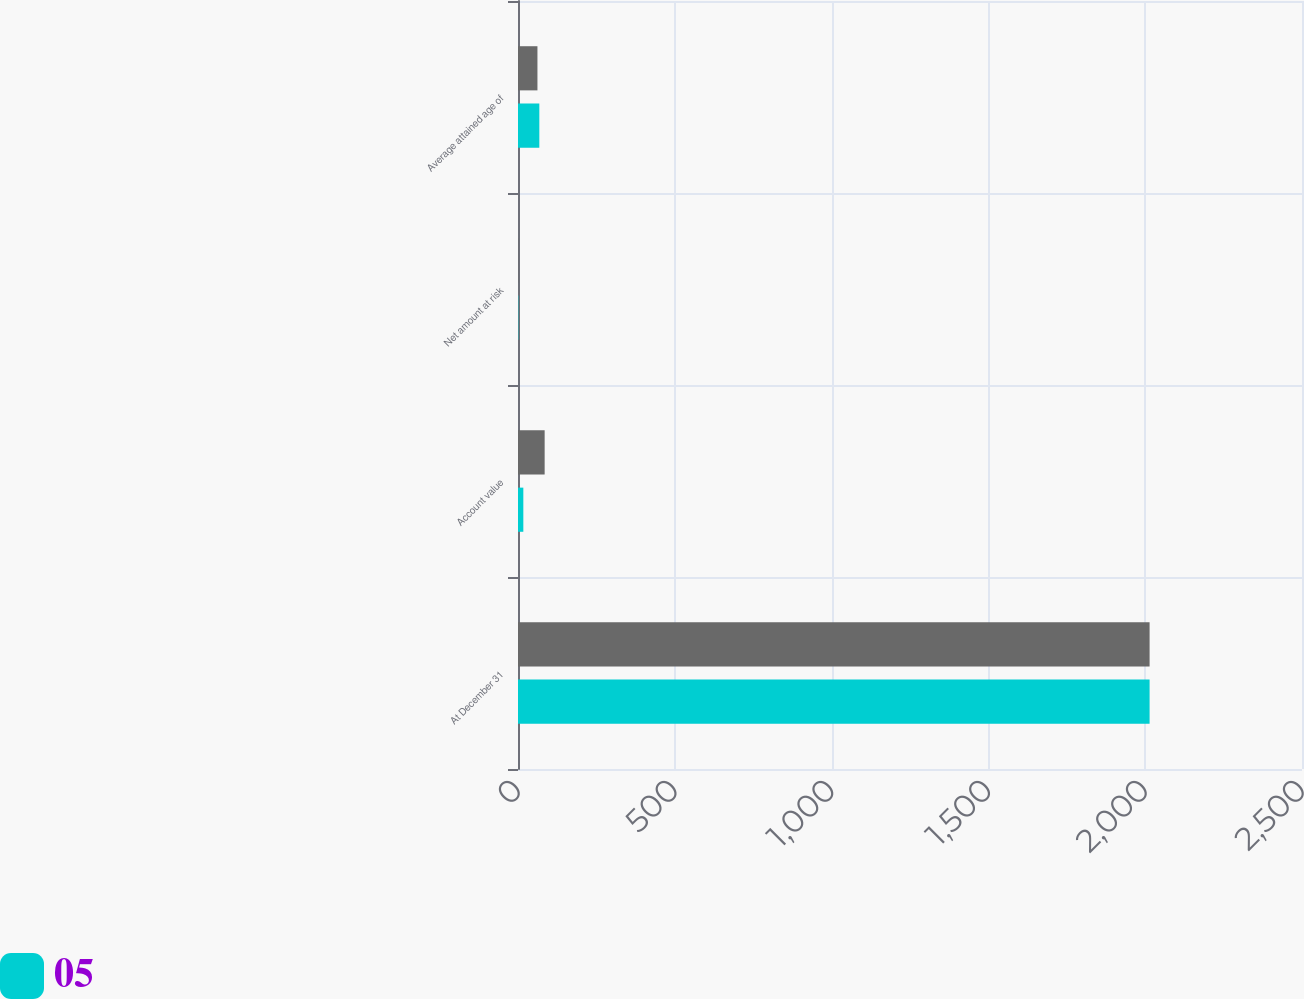<chart> <loc_0><loc_0><loc_500><loc_500><stacked_bar_chart><ecel><fcel>At December 31<fcel>Account value<fcel>Net amount at risk<fcel>Average attained age of<nl><fcel>nan<fcel>2014<fcel>85<fcel>1<fcel>62<nl><fcel>5<fcel>2014<fcel>17<fcel>1<fcel>68<nl></chart> 